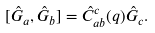Convert formula to latex. <formula><loc_0><loc_0><loc_500><loc_500>[ \hat { G } _ { a } , \hat { G } _ { b } ] = \hat { C } _ { a b } ^ { c } ( q ) \hat { G } _ { c } .</formula> 